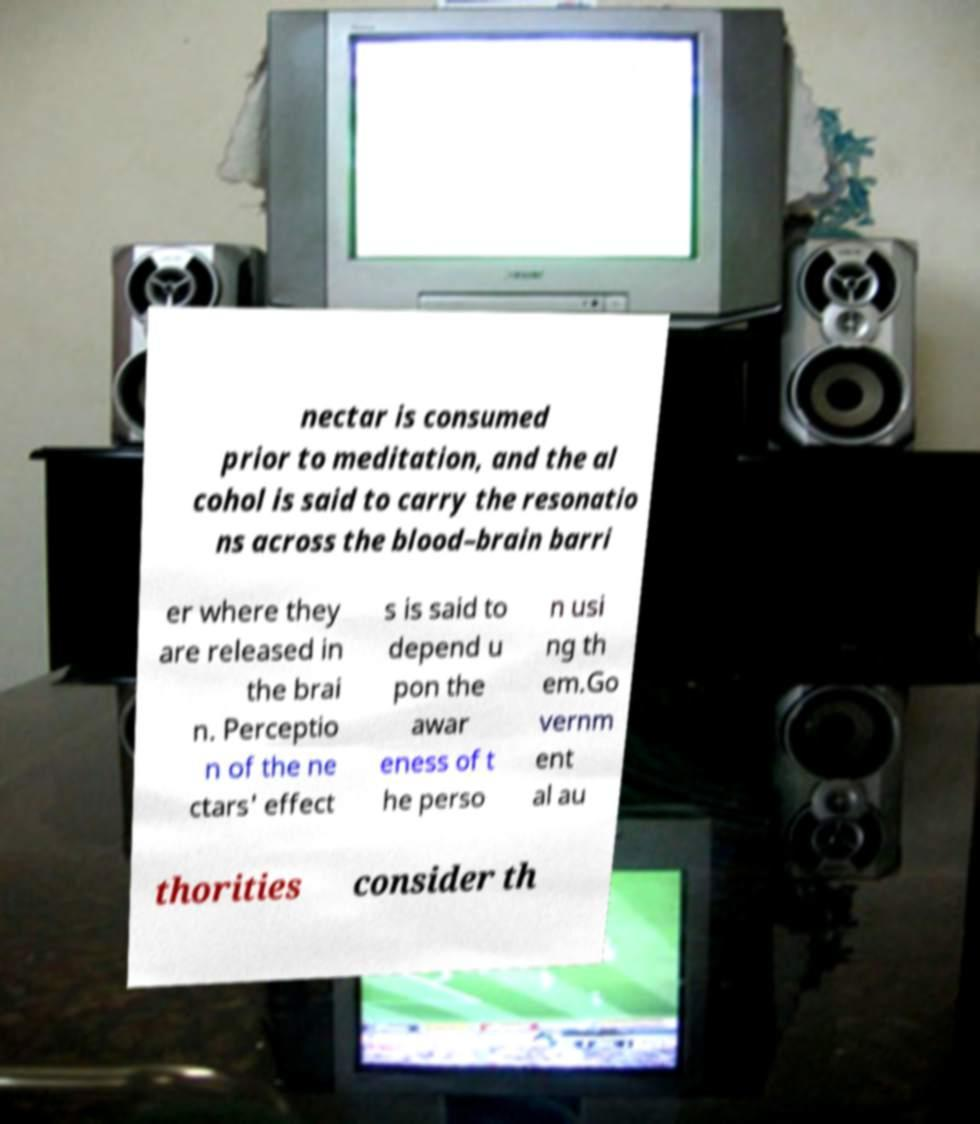Could you assist in decoding the text presented in this image and type it out clearly? nectar is consumed prior to meditation, and the al cohol is said to carry the resonatio ns across the blood–brain barri er where they are released in the brai n. Perceptio n of the ne ctars' effect s is said to depend u pon the awar eness of t he perso n usi ng th em.Go vernm ent al au thorities consider th 